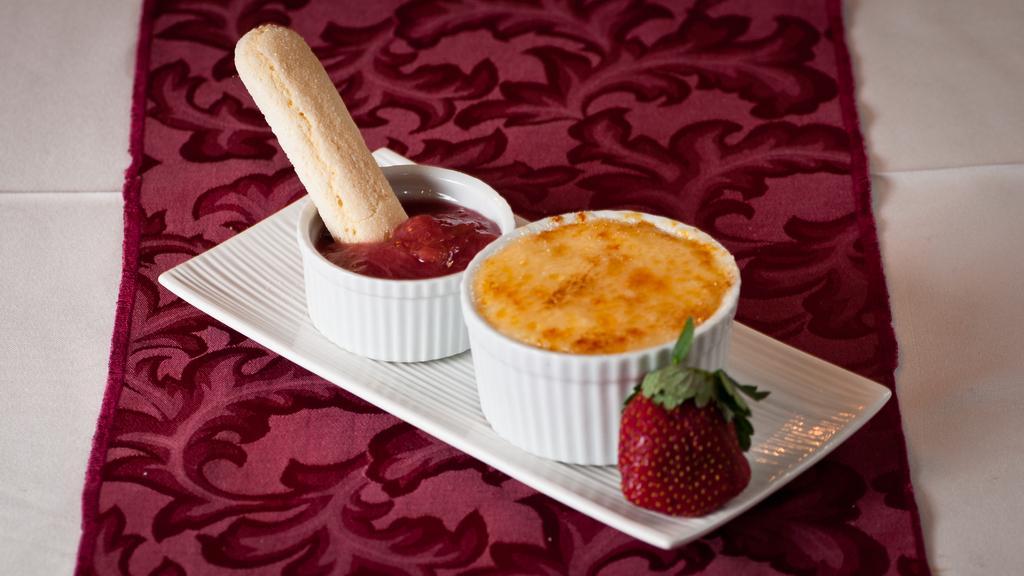How would you summarize this image in a sentence or two? As we can see in the image there are white color tiles, mat, tray, bowls and strawberry. In bowls there are dishes. 